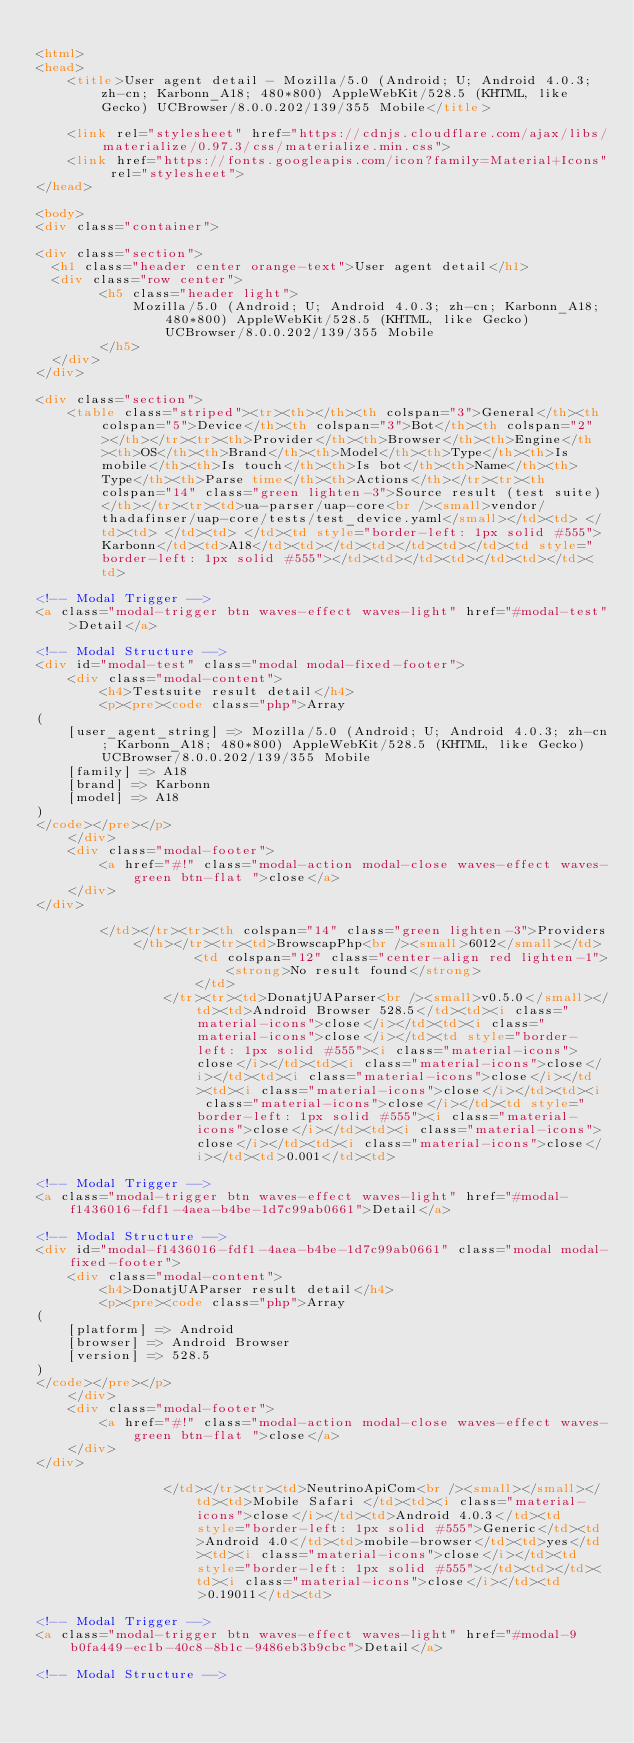Convert code to text. <code><loc_0><loc_0><loc_500><loc_500><_HTML_>
<html>
<head>
    <title>User agent detail - Mozilla/5.0 (Android; U; Android 4.0.3; zh-cn; Karbonn_A18; 480*800) AppleWebKit/528.5 (KHTML, like Gecko) UCBrowser/8.0.0.202/139/355 Mobile</title>
        
    <link rel="stylesheet" href="https://cdnjs.cloudflare.com/ajax/libs/materialize/0.97.3/css/materialize.min.css">
    <link href="https://fonts.googleapis.com/icon?family=Material+Icons" rel="stylesheet">
</head>
        
<body>
<div class="container">
    
<div class="section">
	<h1 class="header center orange-text">User agent detail</h1>
	<div class="row center">
        <h5 class="header light">
            Mozilla/5.0 (Android; U; Android 4.0.3; zh-cn; Karbonn_A18; 480*800) AppleWebKit/528.5 (KHTML, like Gecko) UCBrowser/8.0.0.202/139/355 Mobile
        </h5>
	</div>
</div>   

<div class="section">
    <table class="striped"><tr><th></th><th colspan="3">General</th><th colspan="5">Device</th><th colspan="3">Bot</th><th colspan="2"></th></tr><tr><th>Provider</th><th>Browser</th><th>Engine</th><th>OS</th><th>Brand</th><th>Model</th><th>Type</th><th>Is mobile</th><th>Is touch</th><th>Is bot</th><th>Name</th><th>Type</th><th>Parse time</th><th>Actions</th></tr><tr><th colspan="14" class="green lighten-3">Source result (test suite)</th></tr><tr><td>ua-parser/uap-core<br /><small>vendor/thadafinser/uap-core/tests/test_device.yaml</small></td><td> </td><td> </td><td> </td><td style="border-left: 1px solid #555">Karbonn</td><td>A18</td><td></td><td></td><td></td><td style="border-left: 1px solid #555"></td><td></td><td></td><td></td><td>
                
<!-- Modal Trigger -->
<a class="modal-trigger btn waves-effect waves-light" href="#modal-test">Detail</a>

<!-- Modal Structure -->
<div id="modal-test" class="modal modal-fixed-footer">
    <div class="modal-content">
        <h4>Testsuite result detail</h4>
        <p><pre><code class="php">Array
(
    [user_agent_string] => Mozilla/5.0 (Android; U; Android 4.0.3; zh-cn; Karbonn_A18; 480*800) AppleWebKit/528.5 (KHTML, like Gecko) UCBrowser/8.0.0.202/139/355 Mobile
    [family] => A18
    [brand] => Karbonn
    [model] => A18
)
</code></pre></p>
    </div>
    <div class="modal-footer">
        <a href="#!" class="modal-action modal-close waves-effect waves-green btn-flat ">close</a>
    </div>
</div>
                
        </td></tr><tr><th colspan="14" class="green lighten-3">Providers</th></tr><tr><td>BrowscapPhp<br /><small>6012</small></td>
                    <td colspan="12" class="center-align red lighten-1">
                        <strong>No result found</strong>
                    </td>
                </tr><tr><td>DonatjUAParser<br /><small>v0.5.0</small></td><td>Android Browser 528.5</td><td><i class="material-icons">close</i></td><td><i class="material-icons">close</i></td><td style="border-left: 1px solid #555"><i class="material-icons">close</i></td><td><i class="material-icons">close</i></td><td><i class="material-icons">close</i></td><td><i class="material-icons">close</i></td><td><i class="material-icons">close</i></td><td style="border-left: 1px solid #555"><i class="material-icons">close</i></td><td><i class="material-icons">close</i></td><td><i class="material-icons">close</i></td><td>0.001</td><td>
                
<!-- Modal Trigger -->
<a class="modal-trigger btn waves-effect waves-light" href="#modal-f1436016-fdf1-4aea-b4be-1d7c99ab0661">Detail</a>

<!-- Modal Structure -->
<div id="modal-f1436016-fdf1-4aea-b4be-1d7c99ab0661" class="modal modal-fixed-footer">
    <div class="modal-content">
        <h4>DonatjUAParser result detail</h4>
        <p><pre><code class="php">Array
(
    [platform] => Android
    [browser] => Android Browser
    [version] => 528.5
)
</code></pre></p>
    </div>
    <div class="modal-footer">
        <a href="#!" class="modal-action modal-close waves-effect waves-green btn-flat ">close</a>
    </div>
</div>
                
                </td></tr><tr><td>NeutrinoApiCom<br /><small></small></td><td>Mobile Safari </td><td><i class="material-icons">close</i></td><td>Android 4.0.3</td><td style="border-left: 1px solid #555">Generic</td><td>Android 4.0</td><td>mobile-browser</td><td>yes</td><td><i class="material-icons">close</i></td><td style="border-left: 1px solid #555"></td><td></td><td><i class="material-icons">close</i></td><td>0.19011</td><td>
                
<!-- Modal Trigger -->
<a class="modal-trigger btn waves-effect waves-light" href="#modal-9b0fa449-ec1b-40c8-8b1c-9486eb3b9cbc">Detail</a>

<!-- Modal Structure --></code> 